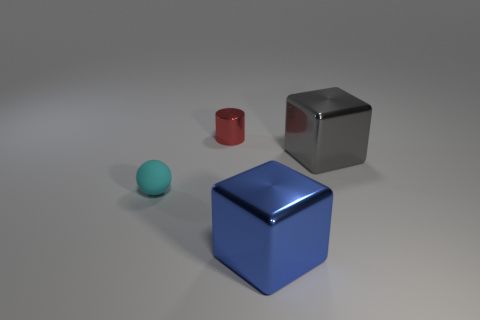Add 2 brown cylinders. How many objects exist? 6 Subtract all cylinders. How many objects are left? 3 Subtract all gray metallic objects. Subtract all big gray things. How many objects are left? 2 Add 1 metallic objects. How many metallic objects are left? 4 Add 1 cyan spheres. How many cyan spheres exist? 2 Subtract 0 purple cubes. How many objects are left? 4 